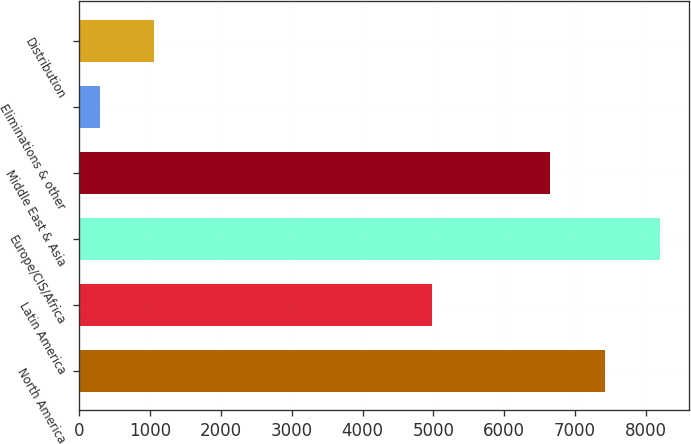Convert chart to OTSL. <chart><loc_0><loc_0><loc_500><loc_500><bar_chart><fcel>North America<fcel>Latin America<fcel>Europe/CIS/Africa<fcel>Middle East & Asia<fcel>Eliminations & other<fcel>Distribution<nl><fcel>7423.9<fcel>4985<fcel>8197.8<fcel>6650<fcel>285<fcel>1058.9<nl></chart> 